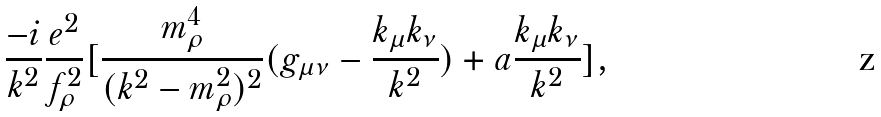Convert formula to latex. <formula><loc_0><loc_0><loc_500><loc_500>\frac { - i } { k ^ { 2 } } \frac { e ^ { 2 } } { f _ { \rho } ^ { 2 } } [ \frac { m _ { \rho } ^ { 4 } } { ( k ^ { 2 } - m _ { \rho } ^ { 2 } ) ^ { 2 } } ( g _ { \mu \nu } - \frac { k _ { \mu } k _ { \nu } } { k ^ { 2 } } ) + a \frac { k _ { \mu } k _ { \nu } } { k ^ { 2 } } ] ,</formula> 